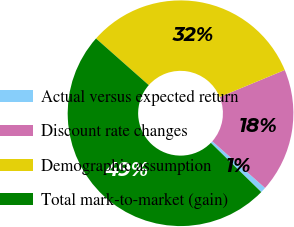<chart> <loc_0><loc_0><loc_500><loc_500><pie_chart><fcel>Actual versus expected return<fcel>Discount rate changes<fcel>Demographic assumption<fcel>Total mark-to-market (gain)<nl><fcel>0.79%<fcel>17.78%<fcel>32.22%<fcel>49.21%<nl></chart> 